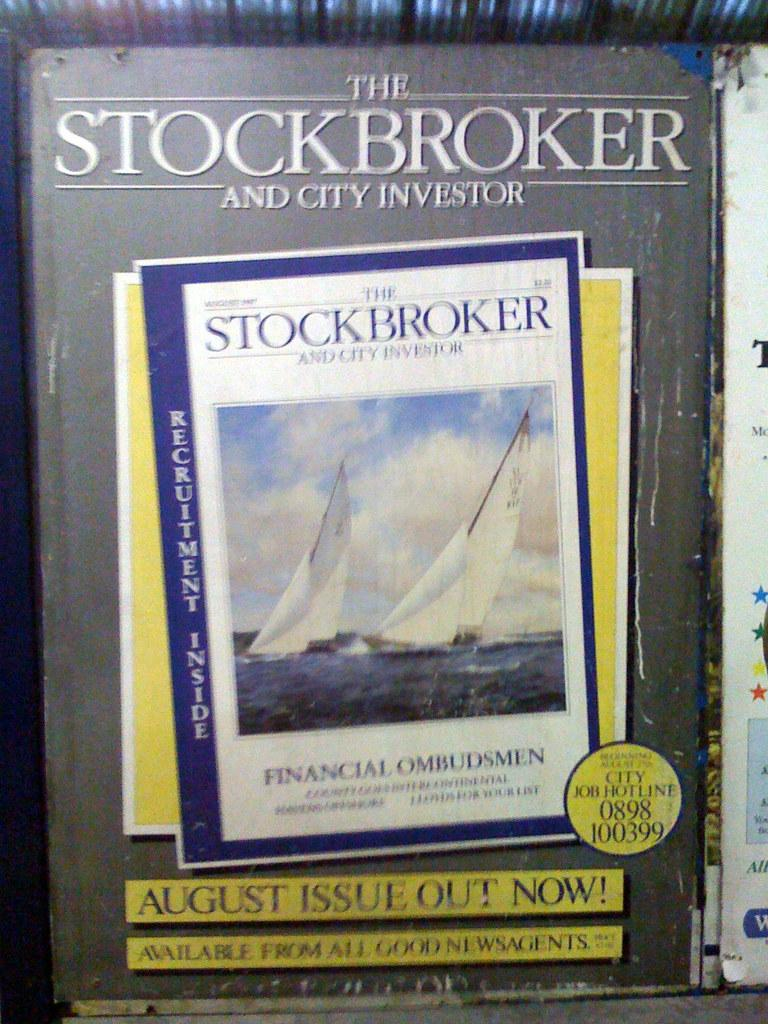Provide a one-sentence caption for the provided image. The Stockbroker and City Investor magazine says that the August issue is out now. 